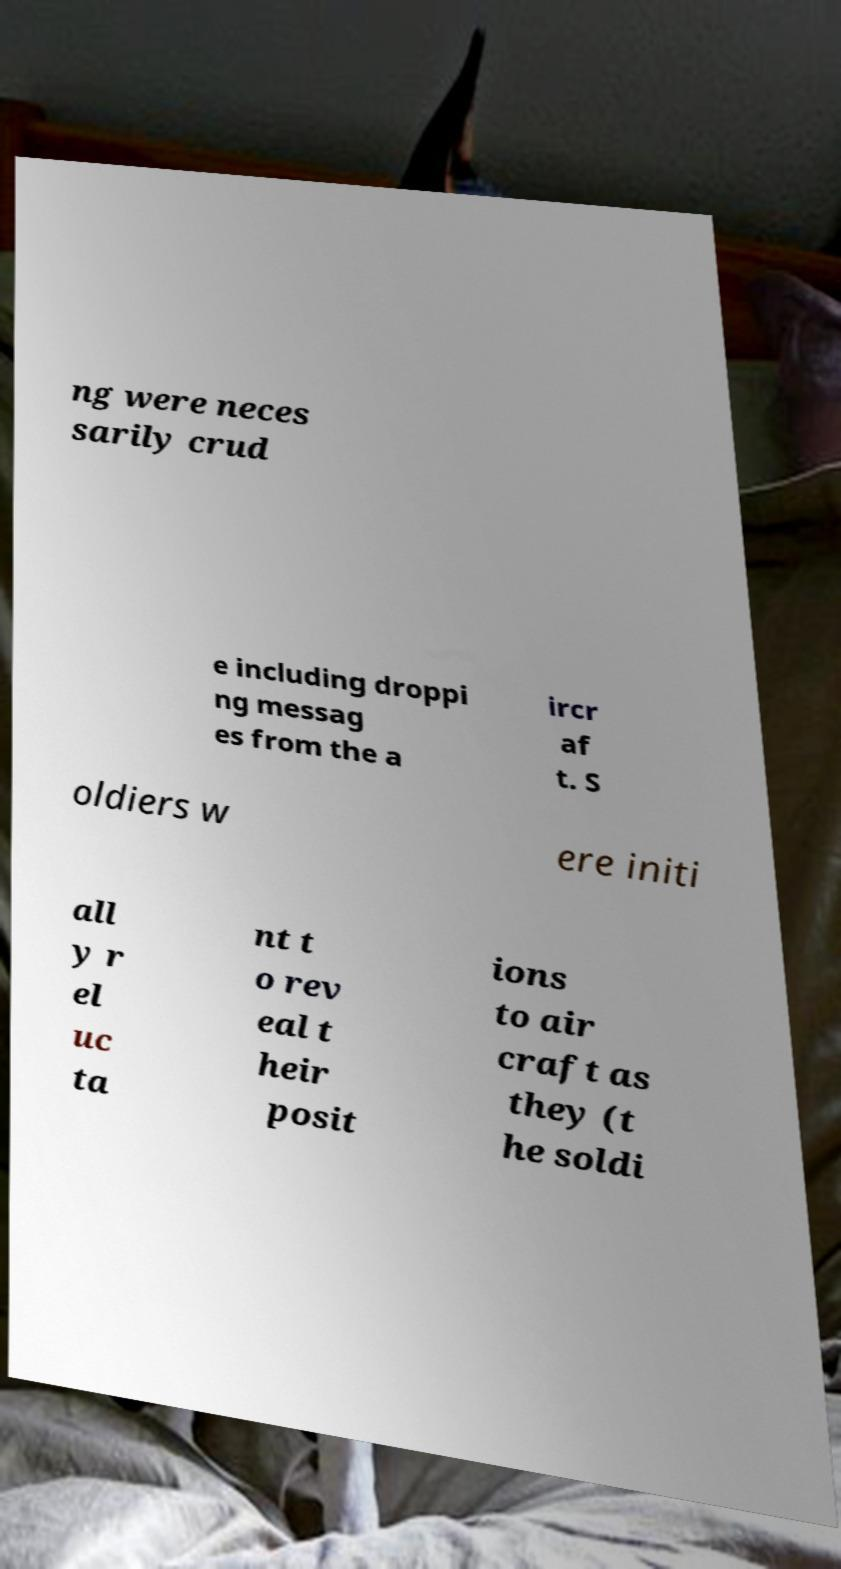Can you read and provide the text displayed in the image?This photo seems to have some interesting text. Can you extract and type it out for me? ng were neces sarily crud e including droppi ng messag es from the a ircr af t. S oldiers w ere initi all y r el uc ta nt t o rev eal t heir posit ions to air craft as they (t he soldi 